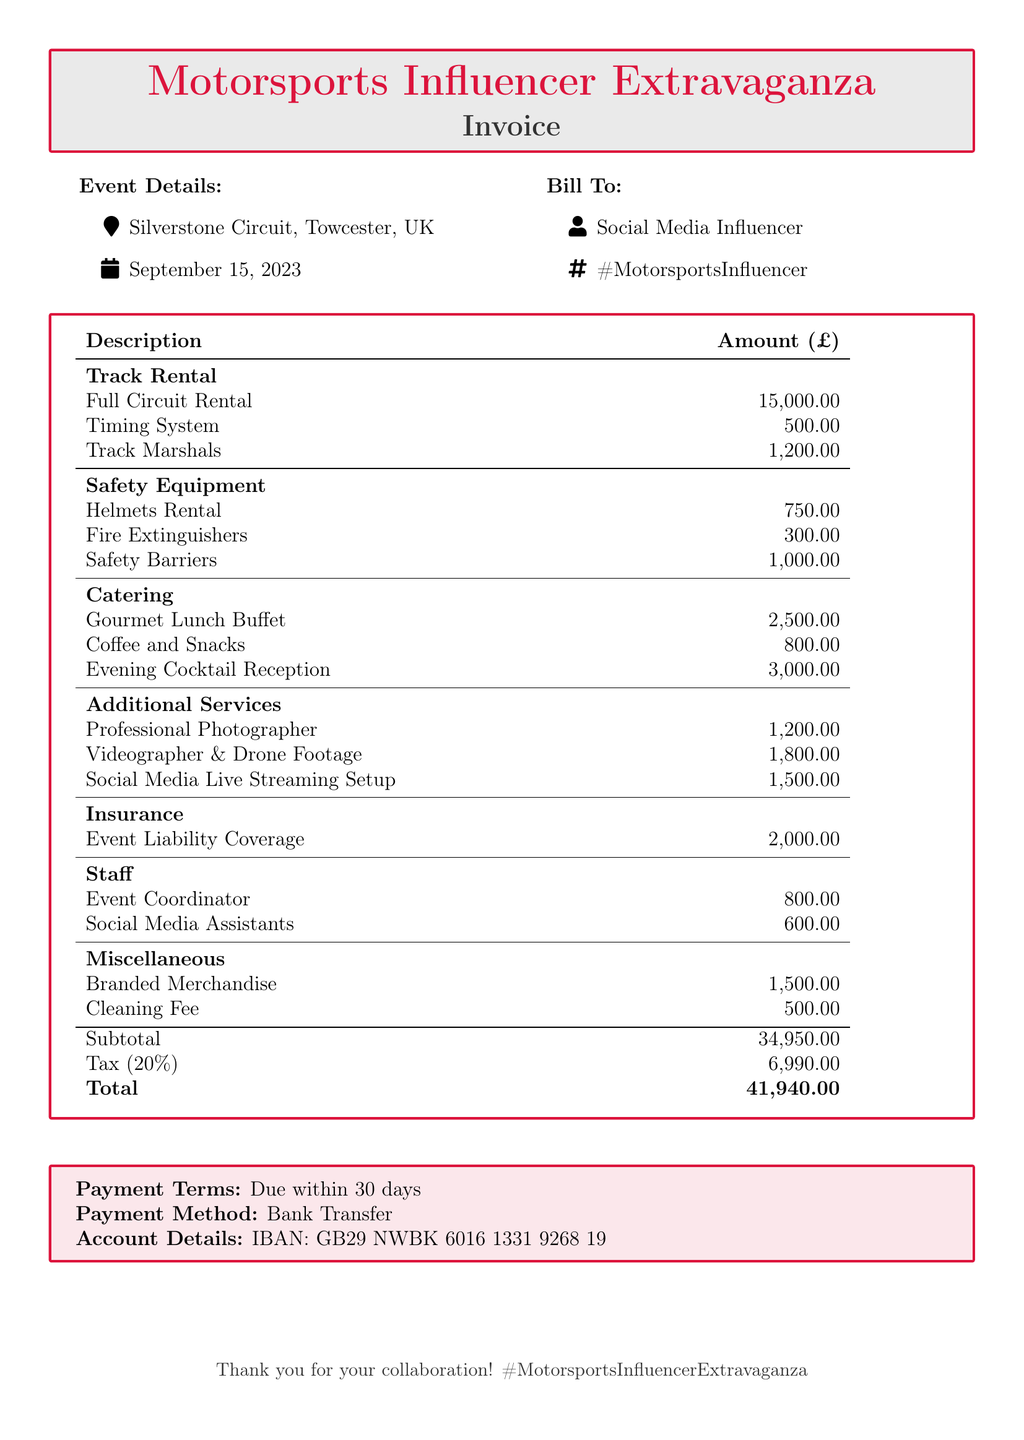What is the total cost of the event? The total cost is listed at the bottom of the invoice and includes all expenses plus tax, which amounts to £41,940.
Answer: £41,940 What is the rental cost for the full circuit? The document specifies a rental cost for the full circuit that is directly stated in the track rental section.
Answer: £15,000.00 When is the event scheduled? The date of the event is mentioned in the document under Event Details section.
Answer: September 15, 2023 How much is charged for the gourmet lunch buffet? The catering section outlines the cost for the gourmet lunch buffet specifically.
Answer: £2,500.00 What is included in the miscellaneous expenses? The miscellaneous section lists two specific items incurred during the event, which are detailed in the document.
Answer: Branded Merchandise and Cleaning Fee What is the tax percentage applied? The tax percentage is explicitly mentioned in the invoice and is calculated based on the subtotal.
Answer: 20% How much will be paid for social media assistants? The amount for social media assistants is listed under the Staff category in the document.
Answer: £600.00 Who is the event coordinator? The document provides the category of staff but does not specify names; however, it indicates the role that requires payment.
Answer: Event Coordinator What type of coverage is included in the insurance? The document specifies the type of insurance coverage provided for the event.
Answer: Event Liability Coverage 